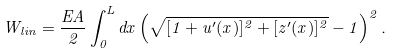Convert formula to latex. <formula><loc_0><loc_0><loc_500><loc_500>W _ { l i n } = \frac { E A } { 2 } \int _ { 0 } ^ { L } d x \left ( \sqrt { [ 1 + u ^ { \prime } ( x ) ] ^ { 2 } + [ z ^ { \prime } ( x ) ] ^ { 2 } } - 1 \right ) ^ { 2 } .</formula> 